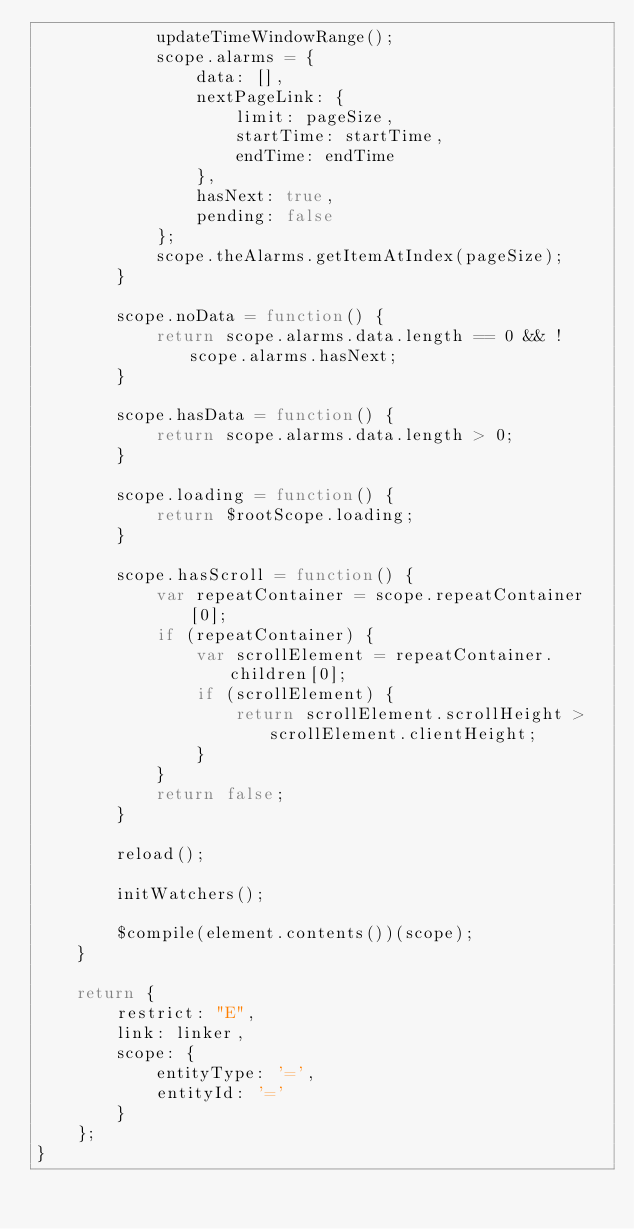<code> <loc_0><loc_0><loc_500><loc_500><_JavaScript_>            updateTimeWindowRange();
            scope.alarms = {
                data: [],
                nextPageLink: {
                    limit: pageSize,
                    startTime: startTime,
                    endTime: endTime
                },
                hasNext: true,
                pending: false
            };
            scope.theAlarms.getItemAtIndex(pageSize);
        }

        scope.noData = function() {
            return scope.alarms.data.length == 0 && !scope.alarms.hasNext;
        }

        scope.hasData = function() {
            return scope.alarms.data.length > 0;
        }

        scope.loading = function() {
            return $rootScope.loading;
        }

        scope.hasScroll = function() {
            var repeatContainer = scope.repeatContainer[0];
            if (repeatContainer) {
                var scrollElement = repeatContainer.children[0];
                if (scrollElement) {
                    return scrollElement.scrollHeight > scrollElement.clientHeight;
                }
            }
            return false;
        }

        reload();

        initWatchers();

        $compile(element.contents())(scope);
    }

    return {
        restrict: "E",
        link: linker,
        scope: {
            entityType: '=',
            entityId: '='
        }
    };
}
</code> 